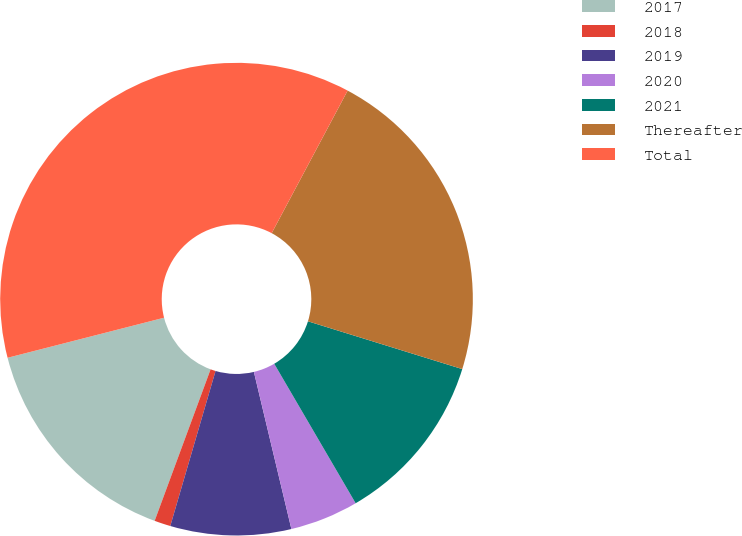<chart> <loc_0><loc_0><loc_500><loc_500><pie_chart><fcel>2017<fcel>2018<fcel>2019<fcel>2020<fcel>2021<fcel>Thereafter<fcel>Total<nl><fcel>15.38%<fcel>1.11%<fcel>8.25%<fcel>4.68%<fcel>11.81%<fcel>21.99%<fcel>36.78%<nl></chart> 